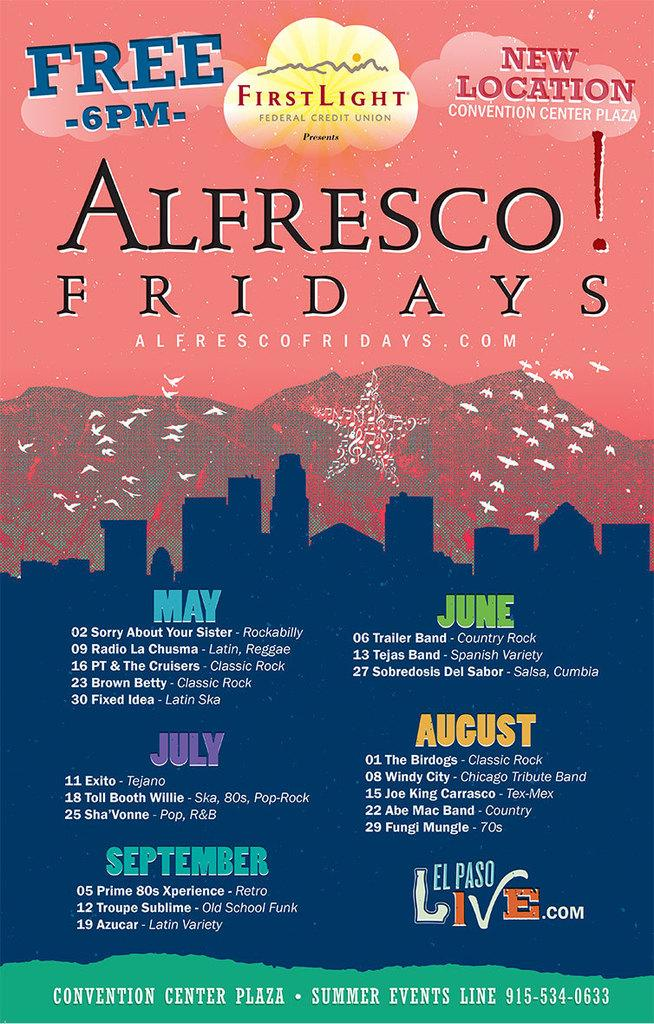<image>
Give a short and clear explanation of the subsequent image. A flyer for First Light Alfresco Fridays list the concert venues broken down per month. 